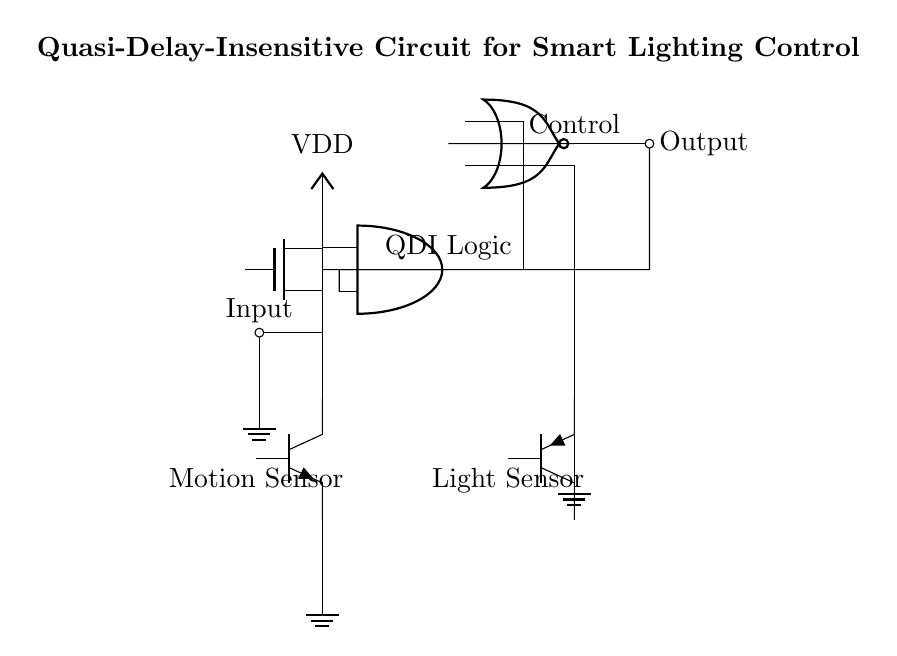What type of logic is used in this circuit? The circuit employs Quasi-Delay-Insensitive (QDI) logic, which is evident from the labeled components and their arrangement indicating the lack of timing constraints.
Answer: QDI logic What does the motion sensor control in the circuit? The motion sensor influences the input to the AND gate, controlling the conditions under which the output signal triggers. This is observed from its connection to one of the AND gate inputs.
Answer: AND gate input What is the role of the light sensor in this circuit? The light sensor provides input to the NOR gate, helping determine the final output state based on light conditions, as indicated by its connection.
Answer: NOR gate input How many outputs does this circuit have? There is one output indicated by the single output node at the end of the circuit, showing how the control signal is ultimately sent out.
Answer: One output Which components are used to sense external conditions? The external conditions are monitored using a motion sensor and a light sensor, each connected to different parts of the circuit affecting the logic states.
Answer: Motion sensor and light sensor What type of feedback is present in the circuit? The feedback in this circuit is negative, as indicated by the connection that returns the output back to the input of the AND gate, creating a loop.
Answer: Negative feedback 